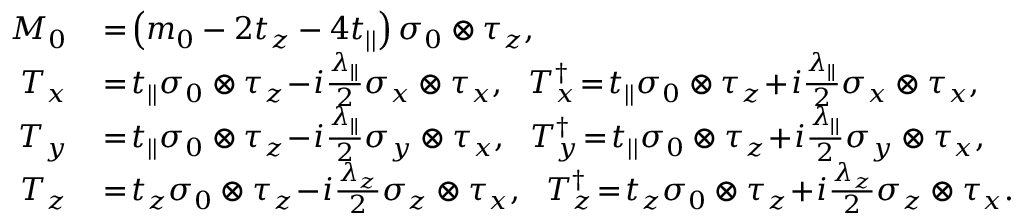Convert formula to latex. <formula><loc_0><loc_0><loc_500><loc_500>\begin{array} { r l } { M _ { 0 } } & \, = \, \left ( m _ { 0 } - 2 t _ { z } - 4 t _ { | | } \right ) \sigma _ { 0 } \otimes \tau _ { z } , } \\ { T _ { x } } & \, = \, t _ { | | } \sigma _ { 0 } \otimes \tau _ { z } \, - \, i \frac { \lambda _ { | | } } { 2 } \sigma _ { x } \otimes \tau _ { x } , T _ { x } ^ { \dagger } \, = \, t _ { | | } \sigma _ { 0 } \otimes \tau _ { z } \, + \, i \frac { \lambda _ { | | } } { 2 } \sigma _ { x } \otimes \tau _ { x } , } \\ { T _ { y } } & \, = \, t _ { | | } \sigma _ { 0 } \otimes \tau _ { z } \, - \, i \frac { \lambda _ { | | } } { 2 } \sigma _ { y } \otimes \tau _ { x } , T _ { y } ^ { \dagger } \, = \, t _ { | | } \sigma _ { 0 } \otimes \tau _ { z } \, + \, i \frac { \lambda _ { | | } } { 2 } \sigma _ { y } \otimes \tau _ { x } , } \\ { T _ { z } } & \, = \, t _ { z } \sigma _ { 0 } \otimes \tau _ { z } \, - \, i \frac { \lambda _ { z } } { 2 } \sigma _ { z } \otimes \tau _ { x } , T _ { z } ^ { \dagger } \, = \, t _ { z } \sigma _ { 0 } \otimes \tau _ { z } \, + \, i \frac { \lambda _ { z } } { 2 } \sigma _ { z } \otimes \tau _ { x } . } \end{array}</formula> 